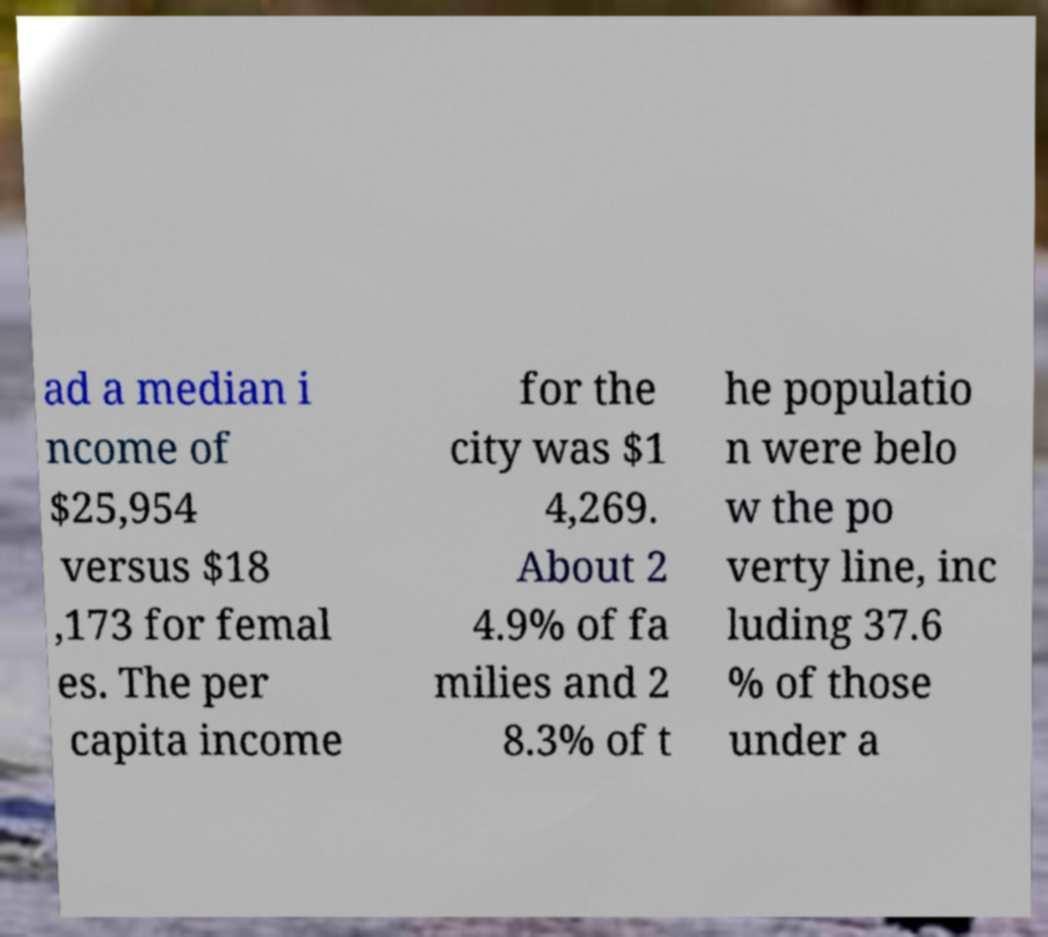What messages or text are displayed in this image? I need them in a readable, typed format. ad a median i ncome of $25,954 versus $18 ,173 for femal es. The per capita income for the city was $1 4,269. About 2 4.9% of fa milies and 2 8.3% of t he populatio n were belo w the po verty line, inc luding 37.6 % of those under a 